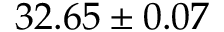<formula> <loc_0><loc_0><loc_500><loc_500>3 2 . 6 5 \pm 0 . 0 7</formula> 